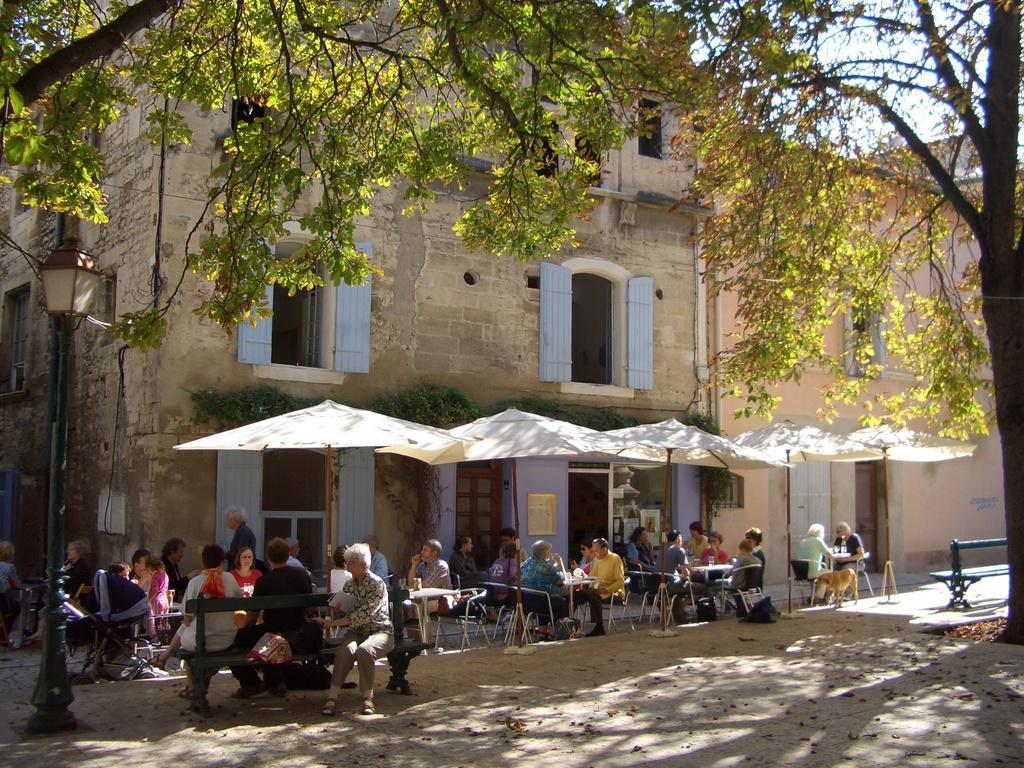Could you give a brief overview of what you see in this image? In this image we can see buildings, trees, windows, street pole, street light, persons sitting on the chairs, persons sitting on the benches under the parasols. In the background there is sky. 